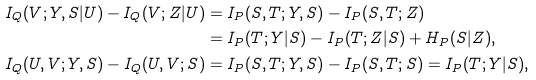<formula> <loc_0><loc_0><loc_500><loc_500>I _ { Q } ( V ; Y , S | U ) - I _ { Q } ( V ; Z | U ) & = I _ { P } ( S , T ; Y , S ) - I _ { P } ( S , T ; Z ) \\ & = I _ { P } ( T ; Y | S ) - I _ { P } ( T ; Z | S ) + H _ { P } ( S | Z ) , \\ I _ { Q } ( U , V ; Y , S ) - I _ { Q } ( U , V ; S ) & = I _ { P } ( S , T ; Y , S ) - I _ { P } ( S , T ; S ) = I _ { P } ( T ; Y | S ) ,</formula> 